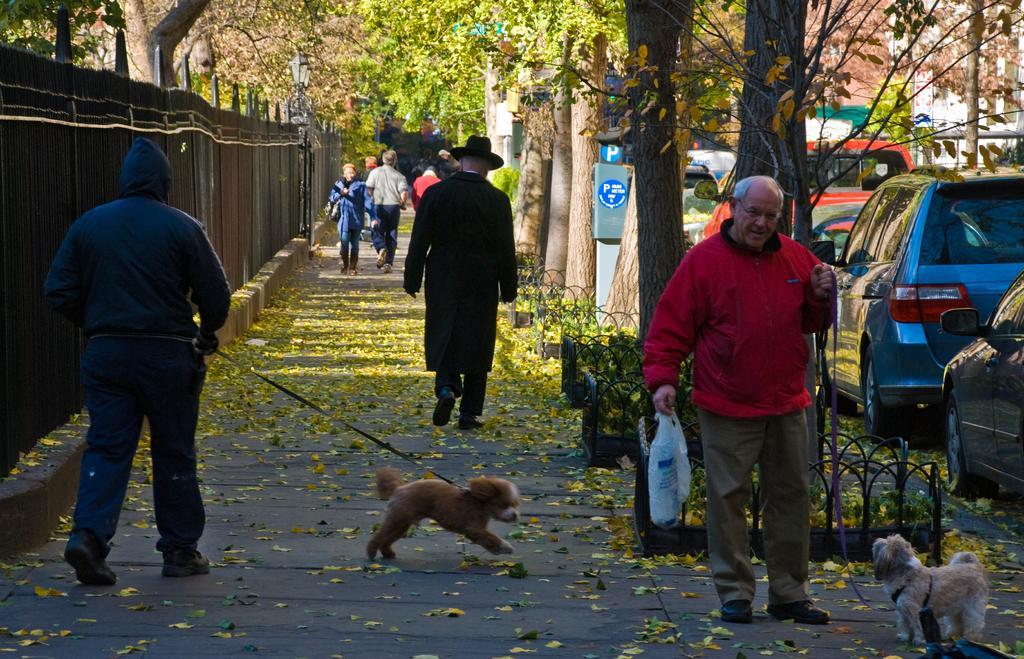Describe this image in one or two sentences. In this picture there are some people those who are walking in the area, there is a man at the right side of the image who is holding a white color bag in his right hand and leach of the dog in his left hand, there are some trees around the area and there are cars at the right side of the image and there is a man who is walking by holding each of his dog and there are iron rods fencing at the left side of the image. 